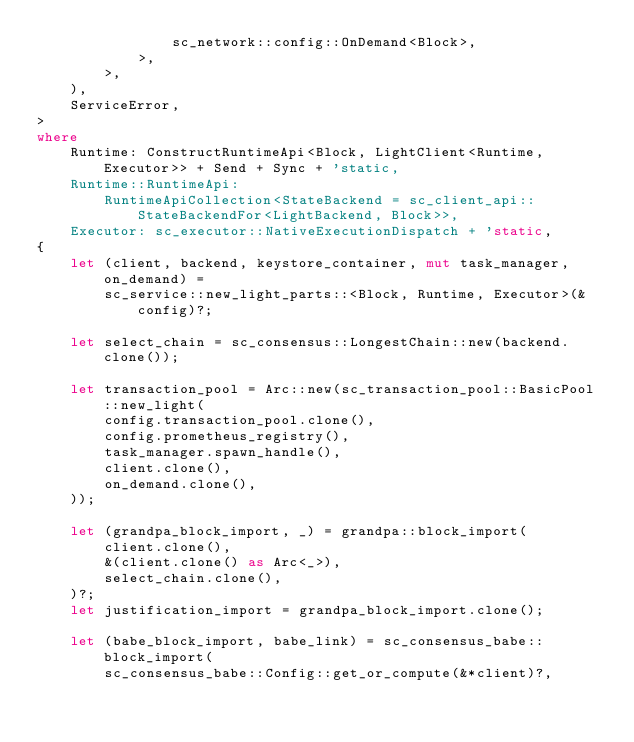<code> <loc_0><loc_0><loc_500><loc_500><_Rust_>                sc_network::config::OnDemand<Block>,
            >,
        >,
    ),
    ServiceError,
>
where
    Runtime: ConstructRuntimeApi<Block, LightClient<Runtime, Executor>> + Send + Sync + 'static,
    Runtime::RuntimeApi:
        RuntimeApiCollection<StateBackend = sc_client_api::StateBackendFor<LightBackend, Block>>,
    Executor: sc_executor::NativeExecutionDispatch + 'static,
{
    let (client, backend, keystore_container, mut task_manager, on_demand) =
        sc_service::new_light_parts::<Block, Runtime, Executor>(&config)?;

    let select_chain = sc_consensus::LongestChain::new(backend.clone());

    let transaction_pool = Arc::new(sc_transaction_pool::BasicPool::new_light(
        config.transaction_pool.clone(),
        config.prometheus_registry(),
        task_manager.spawn_handle(),
        client.clone(),
        on_demand.clone(),
    ));

    let (grandpa_block_import, _) = grandpa::block_import(
        client.clone(),
        &(client.clone() as Arc<_>),
        select_chain.clone(),
    )?;
    let justification_import = grandpa_block_import.clone();

    let (babe_block_import, babe_link) = sc_consensus_babe::block_import(
        sc_consensus_babe::Config::get_or_compute(&*client)?,</code> 